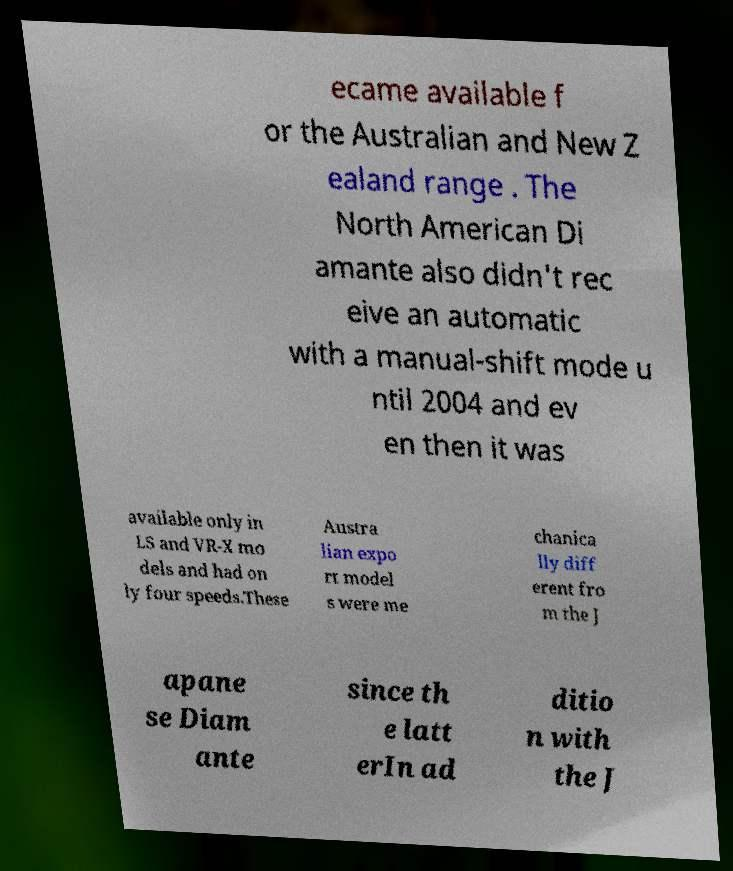Can you accurately transcribe the text from the provided image for me? ecame available f or the Australian and New Z ealand range . The North American Di amante also didn't rec eive an automatic with a manual-shift mode u ntil 2004 and ev en then it was available only in LS and VR-X mo dels and had on ly four speeds.These Austra lian expo rt model s were me chanica lly diff erent fro m the J apane se Diam ante since th e latt erIn ad ditio n with the J 